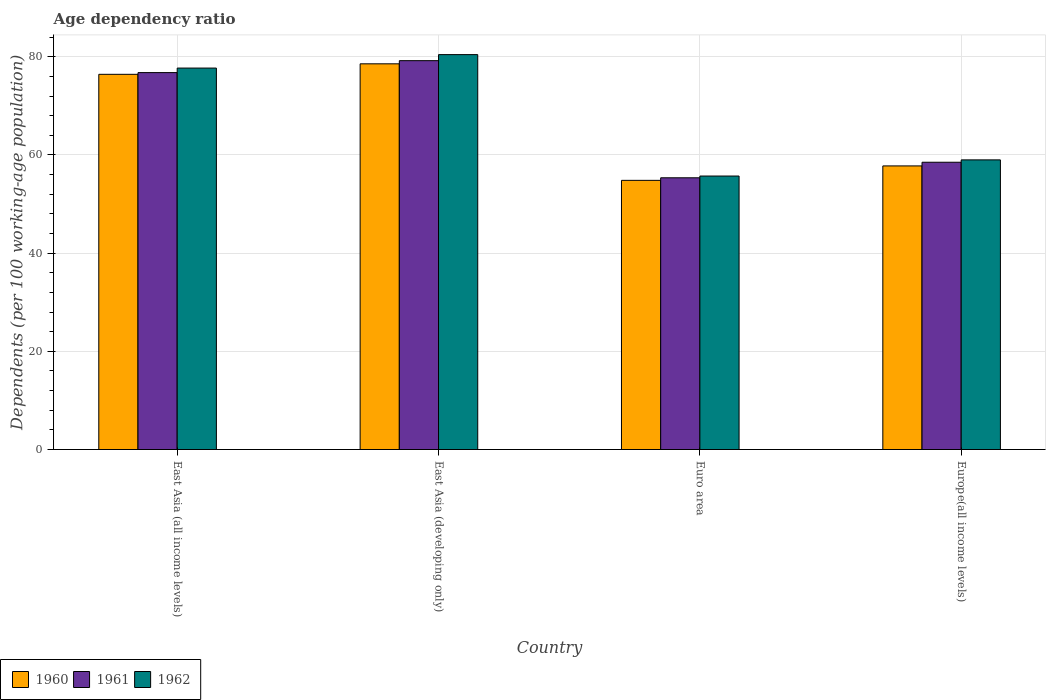How many different coloured bars are there?
Keep it short and to the point. 3. Are the number of bars on each tick of the X-axis equal?
Provide a succinct answer. Yes. How many bars are there on the 4th tick from the left?
Your response must be concise. 3. In how many cases, is the number of bars for a given country not equal to the number of legend labels?
Offer a terse response. 0. What is the age dependency ratio in in 1960 in Euro area?
Ensure brevity in your answer.  54.83. Across all countries, what is the maximum age dependency ratio in in 1962?
Give a very brief answer. 80.45. Across all countries, what is the minimum age dependency ratio in in 1960?
Ensure brevity in your answer.  54.83. In which country was the age dependency ratio in in 1960 maximum?
Give a very brief answer. East Asia (developing only). What is the total age dependency ratio in in 1961 in the graph?
Provide a succinct answer. 269.88. What is the difference between the age dependency ratio in in 1961 in East Asia (all income levels) and that in Europe(all income levels)?
Your answer should be compact. 18.26. What is the difference between the age dependency ratio in in 1962 in Europe(all income levels) and the age dependency ratio in in 1960 in East Asia (all income levels)?
Your answer should be very brief. -17.43. What is the average age dependency ratio in in 1961 per country?
Give a very brief answer. 67.47. What is the difference between the age dependency ratio in of/in 1961 and age dependency ratio in of/in 1960 in Euro area?
Give a very brief answer. 0.52. In how many countries, is the age dependency ratio in in 1962 greater than 24 %?
Make the answer very short. 4. What is the ratio of the age dependency ratio in in 1961 in East Asia (developing only) to that in Euro area?
Provide a succinct answer. 1.43. Is the difference between the age dependency ratio in in 1961 in Euro area and Europe(all income levels) greater than the difference between the age dependency ratio in in 1960 in Euro area and Europe(all income levels)?
Your response must be concise. No. What is the difference between the highest and the second highest age dependency ratio in in 1962?
Keep it short and to the point. 21.44. What is the difference between the highest and the lowest age dependency ratio in in 1962?
Your answer should be very brief. 24.73. In how many countries, is the age dependency ratio in in 1962 greater than the average age dependency ratio in in 1962 taken over all countries?
Give a very brief answer. 2. Is the sum of the age dependency ratio in in 1962 in East Asia (developing only) and Euro area greater than the maximum age dependency ratio in in 1960 across all countries?
Provide a succinct answer. Yes. What does the 1st bar from the left in Euro area represents?
Your response must be concise. 1960. How many bars are there?
Provide a short and direct response. 12. Where does the legend appear in the graph?
Provide a short and direct response. Bottom left. What is the title of the graph?
Your response must be concise. Age dependency ratio. What is the label or title of the X-axis?
Provide a short and direct response. Country. What is the label or title of the Y-axis?
Ensure brevity in your answer.  Dependents (per 100 working-age population). What is the Dependents (per 100 working-age population) in 1960 in East Asia (all income levels)?
Provide a succinct answer. 76.43. What is the Dependents (per 100 working-age population) in 1961 in East Asia (all income levels)?
Keep it short and to the point. 76.79. What is the Dependents (per 100 working-age population) in 1962 in East Asia (all income levels)?
Offer a terse response. 77.71. What is the Dependents (per 100 working-age population) of 1960 in East Asia (developing only)?
Offer a very short reply. 78.57. What is the Dependents (per 100 working-age population) of 1961 in East Asia (developing only)?
Keep it short and to the point. 79.22. What is the Dependents (per 100 working-age population) in 1962 in East Asia (developing only)?
Keep it short and to the point. 80.45. What is the Dependents (per 100 working-age population) in 1960 in Euro area?
Your response must be concise. 54.83. What is the Dependents (per 100 working-age population) of 1961 in Euro area?
Ensure brevity in your answer.  55.36. What is the Dependents (per 100 working-age population) in 1962 in Euro area?
Provide a succinct answer. 55.71. What is the Dependents (per 100 working-age population) in 1960 in Europe(all income levels)?
Keep it short and to the point. 57.77. What is the Dependents (per 100 working-age population) in 1961 in Europe(all income levels)?
Offer a terse response. 58.52. What is the Dependents (per 100 working-age population) in 1962 in Europe(all income levels)?
Keep it short and to the point. 59.01. Across all countries, what is the maximum Dependents (per 100 working-age population) of 1960?
Your answer should be very brief. 78.57. Across all countries, what is the maximum Dependents (per 100 working-age population) in 1961?
Provide a succinct answer. 79.22. Across all countries, what is the maximum Dependents (per 100 working-age population) of 1962?
Your response must be concise. 80.45. Across all countries, what is the minimum Dependents (per 100 working-age population) of 1960?
Ensure brevity in your answer.  54.83. Across all countries, what is the minimum Dependents (per 100 working-age population) of 1961?
Give a very brief answer. 55.36. Across all countries, what is the minimum Dependents (per 100 working-age population) of 1962?
Provide a short and direct response. 55.71. What is the total Dependents (per 100 working-age population) in 1960 in the graph?
Your answer should be compact. 267.62. What is the total Dependents (per 100 working-age population) of 1961 in the graph?
Provide a short and direct response. 269.88. What is the total Dependents (per 100 working-age population) of 1962 in the graph?
Your response must be concise. 272.87. What is the difference between the Dependents (per 100 working-age population) of 1960 in East Asia (all income levels) and that in East Asia (developing only)?
Your response must be concise. -2.14. What is the difference between the Dependents (per 100 working-age population) of 1961 in East Asia (all income levels) and that in East Asia (developing only)?
Keep it short and to the point. -2.43. What is the difference between the Dependents (per 100 working-age population) of 1962 in East Asia (all income levels) and that in East Asia (developing only)?
Offer a very short reply. -2.74. What is the difference between the Dependents (per 100 working-age population) in 1960 in East Asia (all income levels) and that in Euro area?
Provide a succinct answer. 21.6. What is the difference between the Dependents (per 100 working-age population) of 1961 in East Asia (all income levels) and that in Euro area?
Offer a terse response. 21.43. What is the difference between the Dependents (per 100 working-age population) in 1962 in East Asia (all income levels) and that in Euro area?
Offer a very short reply. 21.99. What is the difference between the Dependents (per 100 working-age population) in 1960 in East Asia (all income levels) and that in Europe(all income levels)?
Give a very brief answer. 18.66. What is the difference between the Dependents (per 100 working-age population) of 1961 in East Asia (all income levels) and that in Europe(all income levels)?
Give a very brief answer. 18.26. What is the difference between the Dependents (per 100 working-age population) in 1962 in East Asia (all income levels) and that in Europe(all income levels)?
Give a very brief answer. 18.7. What is the difference between the Dependents (per 100 working-age population) in 1960 in East Asia (developing only) and that in Euro area?
Offer a very short reply. 23.74. What is the difference between the Dependents (per 100 working-age population) in 1961 in East Asia (developing only) and that in Euro area?
Give a very brief answer. 23.86. What is the difference between the Dependents (per 100 working-age population) of 1962 in East Asia (developing only) and that in Euro area?
Offer a terse response. 24.73. What is the difference between the Dependents (per 100 working-age population) of 1960 in East Asia (developing only) and that in Europe(all income levels)?
Your response must be concise. 20.8. What is the difference between the Dependents (per 100 working-age population) of 1961 in East Asia (developing only) and that in Europe(all income levels)?
Provide a short and direct response. 20.69. What is the difference between the Dependents (per 100 working-age population) of 1962 in East Asia (developing only) and that in Europe(all income levels)?
Provide a succinct answer. 21.44. What is the difference between the Dependents (per 100 working-age population) in 1960 in Euro area and that in Europe(all income levels)?
Your answer should be compact. -2.94. What is the difference between the Dependents (per 100 working-age population) in 1961 in Euro area and that in Europe(all income levels)?
Your response must be concise. -3.16. What is the difference between the Dependents (per 100 working-age population) in 1962 in Euro area and that in Europe(all income levels)?
Provide a succinct answer. -3.29. What is the difference between the Dependents (per 100 working-age population) in 1960 in East Asia (all income levels) and the Dependents (per 100 working-age population) in 1961 in East Asia (developing only)?
Your answer should be compact. -2.78. What is the difference between the Dependents (per 100 working-age population) of 1960 in East Asia (all income levels) and the Dependents (per 100 working-age population) of 1962 in East Asia (developing only)?
Give a very brief answer. -4.01. What is the difference between the Dependents (per 100 working-age population) of 1961 in East Asia (all income levels) and the Dependents (per 100 working-age population) of 1962 in East Asia (developing only)?
Provide a succinct answer. -3.66. What is the difference between the Dependents (per 100 working-age population) of 1960 in East Asia (all income levels) and the Dependents (per 100 working-age population) of 1961 in Euro area?
Ensure brevity in your answer.  21.08. What is the difference between the Dependents (per 100 working-age population) in 1960 in East Asia (all income levels) and the Dependents (per 100 working-age population) in 1962 in Euro area?
Ensure brevity in your answer.  20.72. What is the difference between the Dependents (per 100 working-age population) of 1961 in East Asia (all income levels) and the Dependents (per 100 working-age population) of 1962 in Euro area?
Keep it short and to the point. 21.07. What is the difference between the Dependents (per 100 working-age population) in 1960 in East Asia (all income levels) and the Dependents (per 100 working-age population) in 1961 in Europe(all income levels)?
Offer a terse response. 17.91. What is the difference between the Dependents (per 100 working-age population) in 1960 in East Asia (all income levels) and the Dependents (per 100 working-age population) in 1962 in Europe(all income levels)?
Give a very brief answer. 17.43. What is the difference between the Dependents (per 100 working-age population) in 1961 in East Asia (all income levels) and the Dependents (per 100 working-age population) in 1962 in Europe(all income levels)?
Provide a succinct answer. 17.78. What is the difference between the Dependents (per 100 working-age population) in 1960 in East Asia (developing only) and the Dependents (per 100 working-age population) in 1961 in Euro area?
Offer a terse response. 23.22. What is the difference between the Dependents (per 100 working-age population) in 1960 in East Asia (developing only) and the Dependents (per 100 working-age population) in 1962 in Euro area?
Offer a terse response. 22.86. What is the difference between the Dependents (per 100 working-age population) of 1961 in East Asia (developing only) and the Dependents (per 100 working-age population) of 1962 in Euro area?
Provide a succinct answer. 23.5. What is the difference between the Dependents (per 100 working-age population) of 1960 in East Asia (developing only) and the Dependents (per 100 working-age population) of 1961 in Europe(all income levels)?
Ensure brevity in your answer.  20.05. What is the difference between the Dependents (per 100 working-age population) of 1960 in East Asia (developing only) and the Dependents (per 100 working-age population) of 1962 in Europe(all income levels)?
Offer a very short reply. 19.57. What is the difference between the Dependents (per 100 working-age population) of 1961 in East Asia (developing only) and the Dependents (per 100 working-age population) of 1962 in Europe(all income levels)?
Your response must be concise. 20.21. What is the difference between the Dependents (per 100 working-age population) of 1960 in Euro area and the Dependents (per 100 working-age population) of 1961 in Europe(all income levels)?
Offer a terse response. -3.69. What is the difference between the Dependents (per 100 working-age population) in 1960 in Euro area and the Dependents (per 100 working-age population) in 1962 in Europe(all income levels)?
Offer a terse response. -4.17. What is the difference between the Dependents (per 100 working-age population) of 1961 in Euro area and the Dependents (per 100 working-age population) of 1962 in Europe(all income levels)?
Give a very brief answer. -3.65. What is the average Dependents (per 100 working-age population) in 1960 per country?
Offer a terse response. 66.9. What is the average Dependents (per 100 working-age population) of 1961 per country?
Give a very brief answer. 67.47. What is the average Dependents (per 100 working-age population) in 1962 per country?
Ensure brevity in your answer.  68.22. What is the difference between the Dependents (per 100 working-age population) of 1960 and Dependents (per 100 working-age population) of 1961 in East Asia (all income levels)?
Ensure brevity in your answer.  -0.35. What is the difference between the Dependents (per 100 working-age population) of 1960 and Dependents (per 100 working-age population) of 1962 in East Asia (all income levels)?
Keep it short and to the point. -1.27. What is the difference between the Dependents (per 100 working-age population) of 1961 and Dependents (per 100 working-age population) of 1962 in East Asia (all income levels)?
Provide a short and direct response. -0.92. What is the difference between the Dependents (per 100 working-age population) of 1960 and Dependents (per 100 working-age population) of 1961 in East Asia (developing only)?
Provide a succinct answer. -0.64. What is the difference between the Dependents (per 100 working-age population) in 1960 and Dependents (per 100 working-age population) in 1962 in East Asia (developing only)?
Make the answer very short. -1.87. What is the difference between the Dependents (per 100 working-age population) in 1961 and Dependents (per 100 working-age population) in 1962 in East Asia (developing only)?
Keep it short and to the point. -1.23. What is the difference between the Dependents (per 100 working-age population) in 1960 and Dependents (per 100 working-age population) in 1961 in Euro area?
Make the answer very short. -0.52. What is the difference between the Dependents (per 100 working-age population) in 1960 and Dependents (per 100 working-age population) in 1962 in Euro area?
Keep it short and to the point. -0.88. What is the difference between the Dependents (per 100 working-age population) in 1961 and Dependents (per 100 working-age population) in 1962 in Euro area?
Your answer should be compact. -0.36. What is the difference between the Dependents (per 100 working-age population) in 1960 and Dependents (per 100 working-age population) in 1961 in Europe(all income levels)?
Keep it short and to the point. -0.75. What is the difference between the Dependents (per 100 working-age population) of 1960 and Dependents (per 100 working-age population) of 1962 in Europe(all income levels)?
Give a very brief answer. -1.23. What is the difference between the Dependents (per 100 working-age population) in 1961 and Dependents (per 100 working-age population) in 1962 in Europe(all income levels)?
Offer a terse response. -0.48. What is the ratio of the Dependents (per 100 working-age population) of 1960 in East Asia (all income levels) to that in East Asia (developing only)?
Make the answer very short. 0.97. What is the ratio of the Dependents (per 100 working-age population) in 1961 in East Asia (all income levels) to that in East Asia (developing only)?
Your answer should be very brief. 0.97. What is the ratio of the Dependents (per 100 working-age population) in 1962 in East Asia (all income levels) to that in East Asia (developing only)?
Give a very brief answer. 0.97. What is the ratio of the Dependents (per 100 working-age population) in 1960 in East Asia (all income levels) to that in Euro area?
Ensure brevity in your answer.  1.39. What is the ratio of the Dependents (per 100 working-age population) in 1961 in East Asia (all income levels) to that in Euro area?
Offer a terse response. 1.39. What is the ratio of the Dependents (per 100 working-age population) of 1962 in East Asia (all income levels) to that in Euro area?
Your response must be concise. 1.39. What is the ratio of the Dependents (per 100 working-age population) in 1960 in East Asia (all income levels) to that in Europe(all income levels)?
Provide a short and direct response. 1.32. What is the ratio of the Dependents (per 100 working-age population) of 1961 in East Asia (all income levels) to that in Europe(all income levels)?
Your response must be concise. 1.31. What is the ratio of the Dependents (per 100 working-age population) in 1962 in East Asia (all income levels) to that in Europe(all income levels)?
Ensure brevity in your answer.  1.32. What is the ratio of the Dependents (per 100 working-age population) of 1960 in East Asia (developing only) to that in Euro area?
Provide a succinct answer. 1.43. What is the ratio of the Dependents (per 100 working-age population) of 1961 in East Asia (developing only) to that in Euro area?
Your answer should be compact. 1.43. What is the ratio of the Dependents (per 100 working-age population) of 1962 in East Asia (developing only) to that in Euro area?
Keep it short and to the point. 1.44. What is the ratio of the Dependents (per 100 working-age population) of 1960 in East Asia (developing only) to that in Europe(all income levels)?
Offer a very short reply. 1.36. What is the ratio of the Dependents (per 100 working-age population) in 1961 in East Asia (developing only) to that in Europe(all income levels)?
Your answer should be compact. 1.35. What is the ratio of the Dependents (per 100 working-age population) of 1962 in East Asia (developing only) to that in Europe(all income levels)?
Make the answer very short. 1.36. What is the ratio of the Dependents (per 100 working-age population) in 1960 in Euro area to that in Europe(all income levels)?
Your answer should be very brief. 0.95. What is the ratio of the Dependents (per 100 working-age population) in 1961 in Euro area to that in Europe(all income levels)?
Offer a terse response. 0.95. What is the ratio of the Dependents (per 100 working-age population) of 1962 in Euro area to that in Europe(all income levels)?
Make the answer very short. 0.94. What is the difference between the highest and the second highest Dependents (per 100 working-age population) in 1960?
Give a very brief answer. 2.14. What is the difference between the highest and the second highest Dependents (per 100 working-age population) in 1961?
Provide a short and direct response. 2.43. What is the difference between the highest and the second highest Dependents (per 100 working-age population) of 1962?
Your response must be concise. 2.74. What is the difference between the highest and the lowest Dependents (per 100 working-age population) of 1960?
Offer a very short reply. 23.74. What is the difference between the highest and the lowest Dependents (per 100 working-age population) of 1961?
Provide a succinct answer. 23.86. What is the difference between the highest and the lowest Dependents (per 100 working-age population) in 1962?
Offer a terse response. 24.73. 